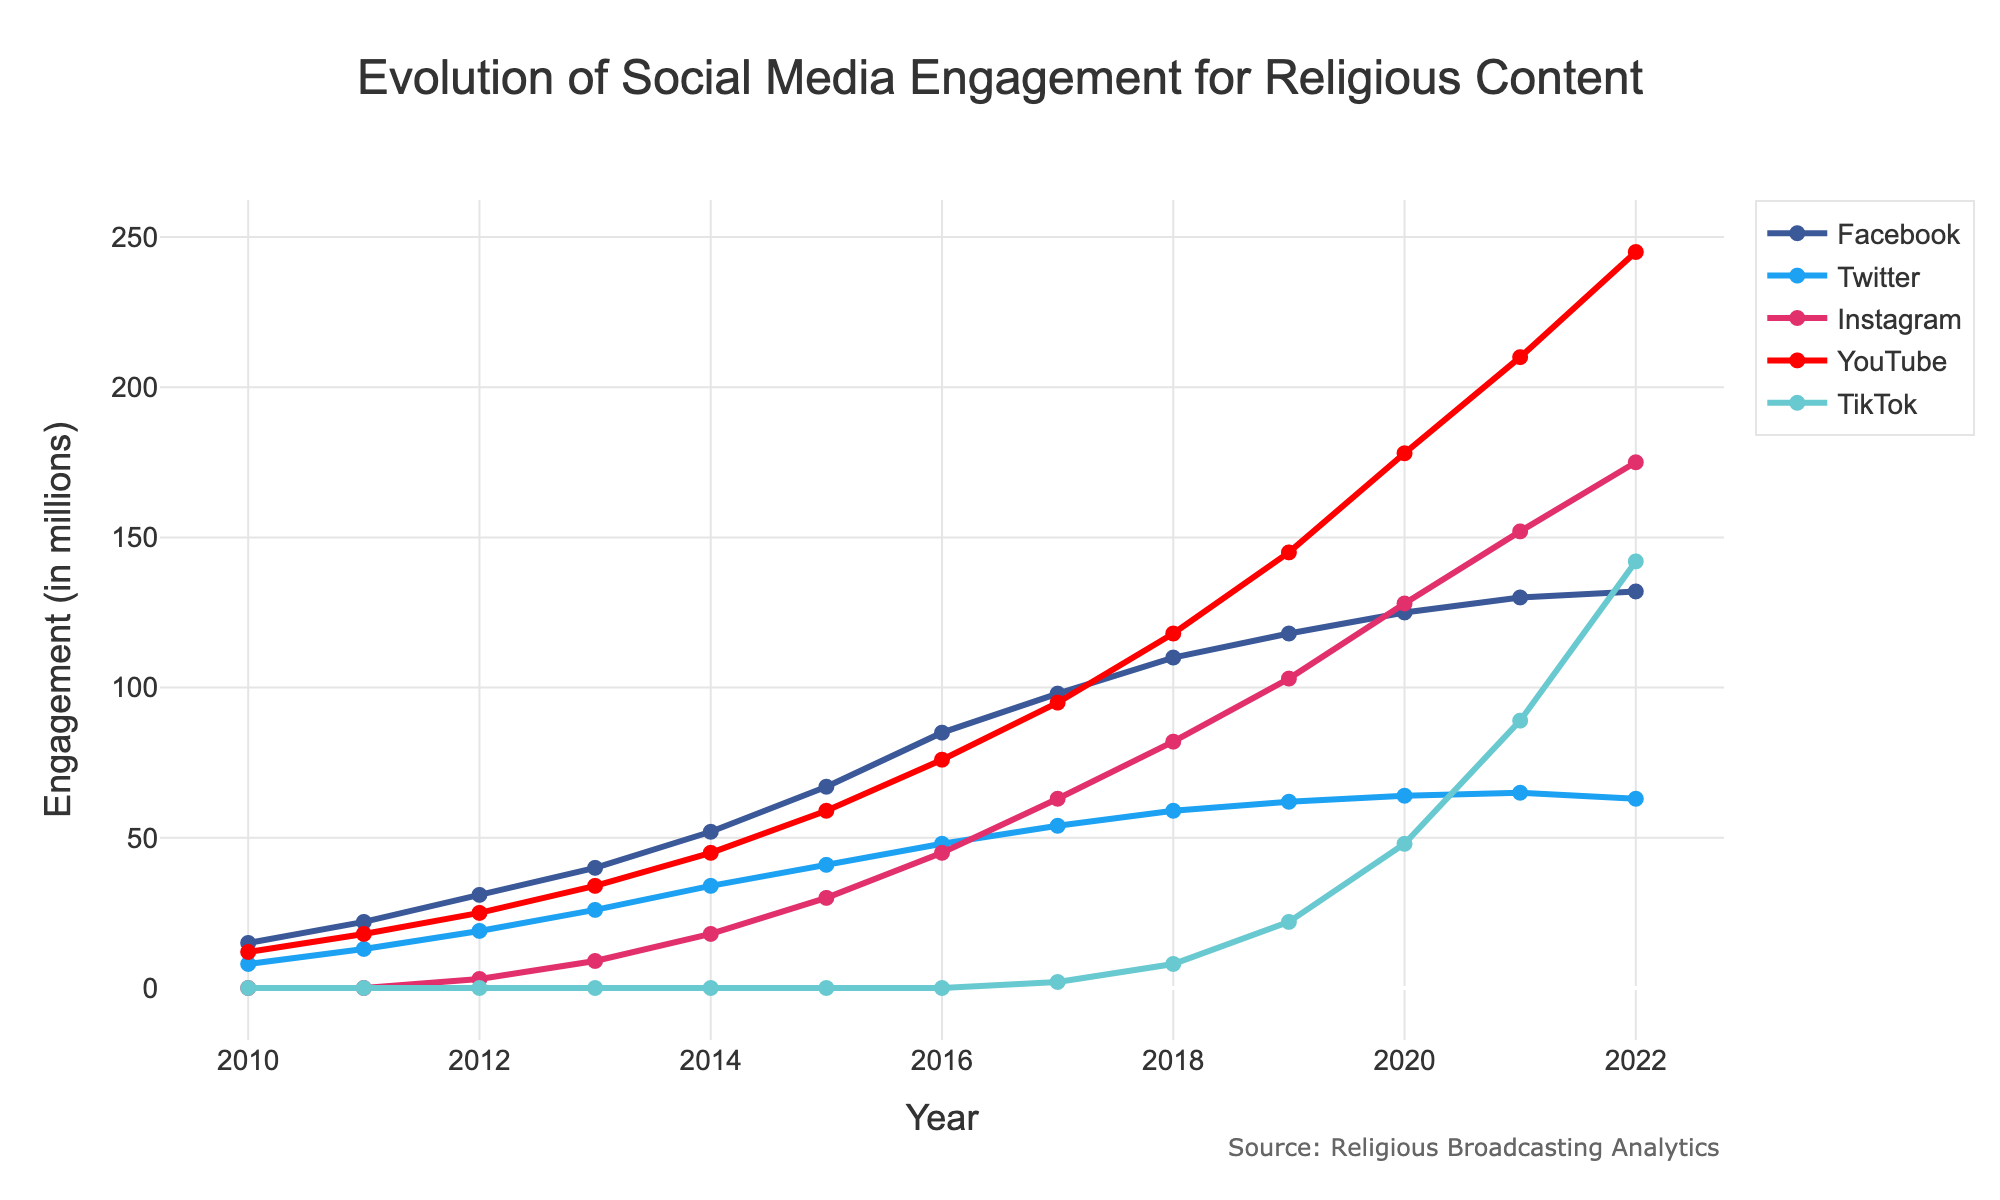Which social media platform showed the highest engagement in 2022? Examine the data points for the year 2022 and identify the highest value across all platforms. The highest engagement in 2022 was on YouTube with 245 million.
Answer: YouTube What's the total engagement for all platforms combined in 2020? Sum the engagement values for all platforms in the year 2020: 125 + 64 + 128 + 178 + 48 = 543.
Answer: 543 Between 2017 and 2018, which platform had the greatest increase in engagement? Calculate the difference in engagement for each platform between 2017 and 2018. Facebook: 110 - 98 = 12, Twitter: 59 - 54 = 5, Instagram: 82 - 63 = 19, YouTube: 118 - 95 = 23, TikTok: 8 - 2 = 6. YouTube had the greatest increase with 23.
Answer: YouTube Which social media platform showed a decline in engagement from 2021 to 2022? Compare the data points for 2021 and 2022 for each platform. Twitter engagement declined from 65 million in 2021 to 63 million in 2022.
Answer: Twitter What is the average engagement across all platforms in 2015? Sum the engagement values for all platforms in 2015 and divide by the number of platforms: (67 + 41 + 30 + 59 + 0) / 5 = 197 / 5 = 39.4.
Answer: 39.4 How many platforms surpassed 50 million engagements in 2019? Examine the engagement values for all platforms in 2019 and count how many are greater than 50 million: Facebook (118), Twitter (62), Instagram (103), YouTube (145). Four platforms surpassed 50 million.
Answer: Four What was the engagement difference between Facebook and TikTok in 2022? Subtract TikTok's engagement from Facebook's engagement in 2022: 132 - 142 = -10.
Answer: -10 Which platform had the smallest growth in engagement between 2020 and 2021? Calculate the difference in engagement for each platform between 2020 and 2021. Facebook: 130 - 125 = 5, Twitter: 65 - 64 = 1, Instagram: 152 - 128 = 24, YouTube: 210 - 178 = 32, TikTok: 89 - 48 = 41. Twitter had the smallest growth with an increase of 1.
Answer: Twitter What is the combined engagement for Facebook and Instagram in 2016? Sum the engagement values for Facebook and Instagram in 2016: 85 + 45 = 130.
Answer: 130 